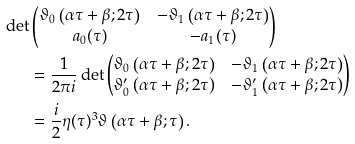<formula> <loc_0><loc_0><loc_500><loc_500>\det & \begin{pmatrix} \vartheta _ { 0 } \left ( \alpha \tau + \beta ; 2 \tau \right ) & - \vartheta _ { 1 } \left ( \alpha \tau + \beta ; 2 \tau \right ) \\ a _ { 0 } ( \tau ) & - a _ { 1 } ( \tau ) \end{pmatrix} \\ & = \frac { 1 } { 2 \pi i } \det \begin{pmatrix} \vartheta _ { 0 } \left ( \alpha \tau + \beta ; 2 \tau \right ) & - \vartheta _ { 1 } \left ( \alpha \tau + \beta ; 2 \tau \right ) \\ \vartheta ^ { \prime } _ { 0 } \left ( \alpha \tau + \beta ; 2 \tau \right ) & - \vartheta ^ { \prime } _ { 1 } \left ( \alpha \tau + \beta ; 2 \tau \right ) \end{pmatrix} \\ & = \frac { i } { 2 } \eta ( \tau ) ^ { 3 } \vartheta \left ( \alpha \tau + \beta ; \tau \right ) .</formula> 